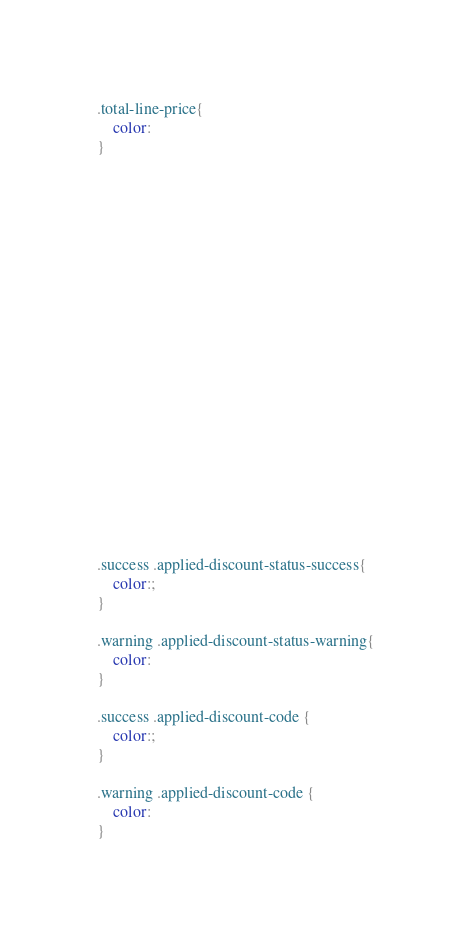<code> <loc_0><loc_0><loc_500><loc_500><_CSS_>











.total-line-price{
	color: 
}





















.success .applied-discount-status-success{
	color:;
}

.warning .applied-discount-status-warning{
	color: 
}

.success .applied-discount-code {
    color:;
}

.warning .applied-discount-code {
    color: 
}</code> 